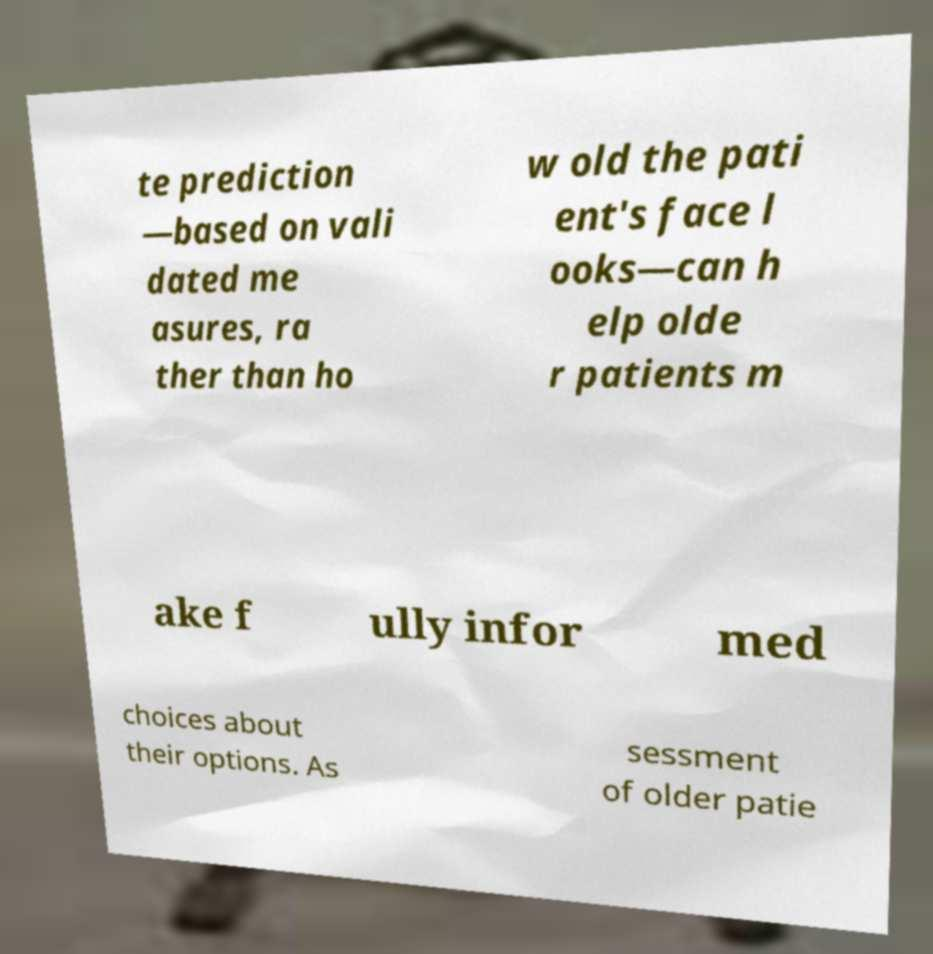There's text embedded in this image that I need extracted. Can you transcribe it verbatim? te prediction —based on vali dated me asures, ra ther than ho w old the pati ent's face l ooks—can h elp olde r patients m ake f ully infor med choices about their options. As sessment of older patie 